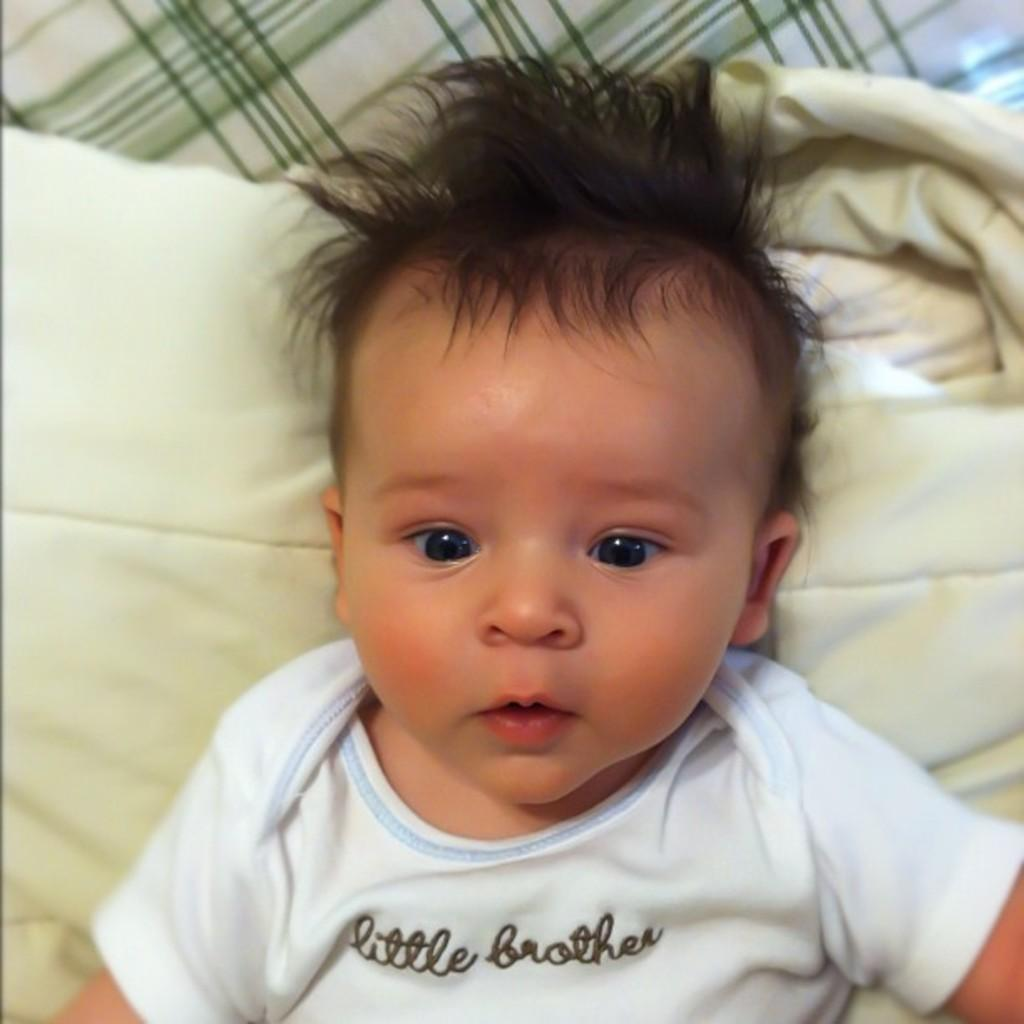What is the main subject of the image? There is a baby in the image. What is the baby wearing? The baby is wearing a white t-shirt. Where is the baby located in the image? The baby is laying on a bed. What type of yak can be seen in the image? There is no yak present in the image; it features a baby laying on a bed. What is the baby doing with the whistle in the image? There is no whistle present in the image, so the baby cannot be doing anything with it. 